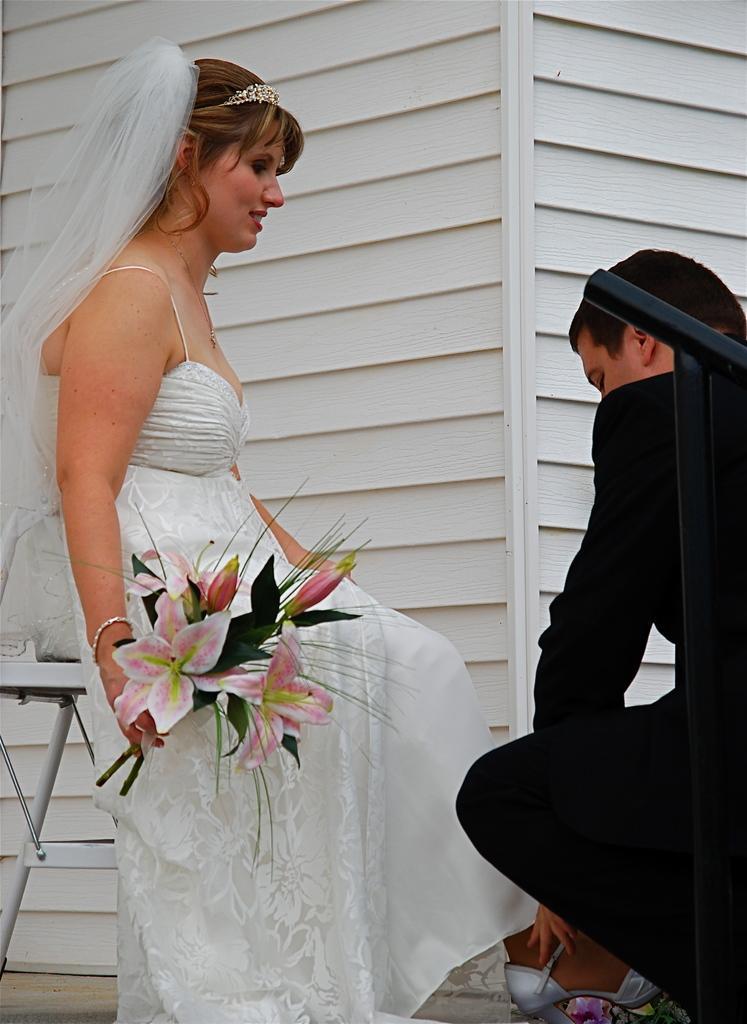Describe this image in one or two sentences. In this picture I can observe a couple. Woman is holding a bouquet in her hand. In the background I can observe wall. 